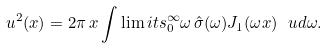Convert formula to latex. <formula><loc_0><loc_0><loc_500><loc_500>u ^ { 2 } ( x ) = 2 \pi \, { x } \int \lim i t s _ { 0 } ^ { \infty } \omega \, \hat { \sigma } ( \omega ) J _ { 1 } ( \omega { x } ) \ u d { \omega } .</formula> 